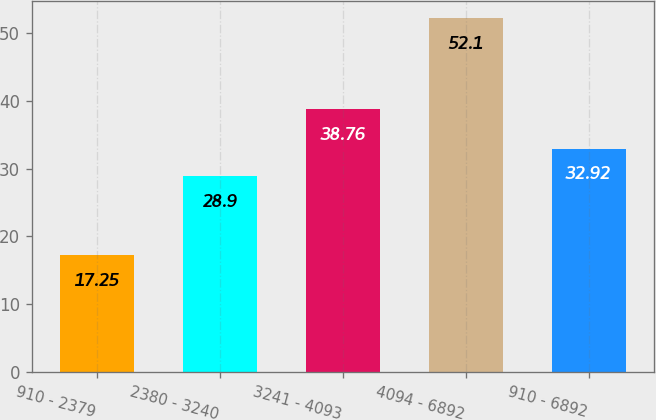<chart> <loc_0><loc_0><loc_500><loc_500><bar_chart><fcel>910 - 2379<fcel>2380 - 3240<fcel>3241 - 4093<fcel>4094 - 6892<fcel>910 - 6892<nl><fcel>17.25<fcel>28.9<fcel>38.76<fcel>52.1<fcel>32.92<nl></chart> 